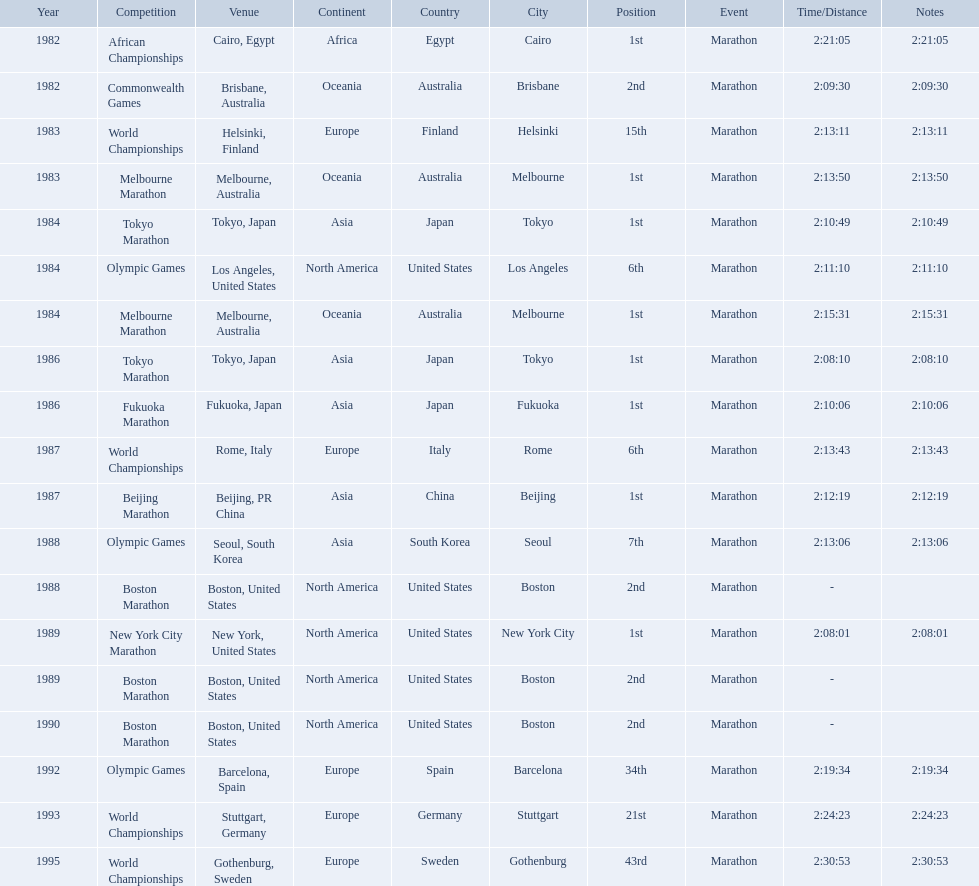What are all the competitions? African Championships, Commonwealth Games, World Championships, Melbourne Marathon, Tokyo Marathon, Olympic Games, Melbourne Marathon, Tokyo Marathon, Fukuoka Marathon, World Championships, Beijing Marathon, Olympic Games, Boston Marathon, New York City Marathon, Boston Marathon, Boston Marathon, Olympic Games, World Championships, World Championships. Where were they located? Cairo, Egypt, Brisbane, Australia, Helsinki, Finland, Melbourne, Australia, Tokyo, Japan, Los Angeles, United States, Melbourne, Australia, Tokyo, Japan, Fukuoka, Japan, Rome, Italy, Beijing, PR China, Seoul, South Korea, Boston, United States, New York, United States, Boston, United States, Boston, United States, Barcelona, Spain, Stuttgart, Germany, Gothenburg, Sweden. And which competition was in china? Beijing Marathon. 